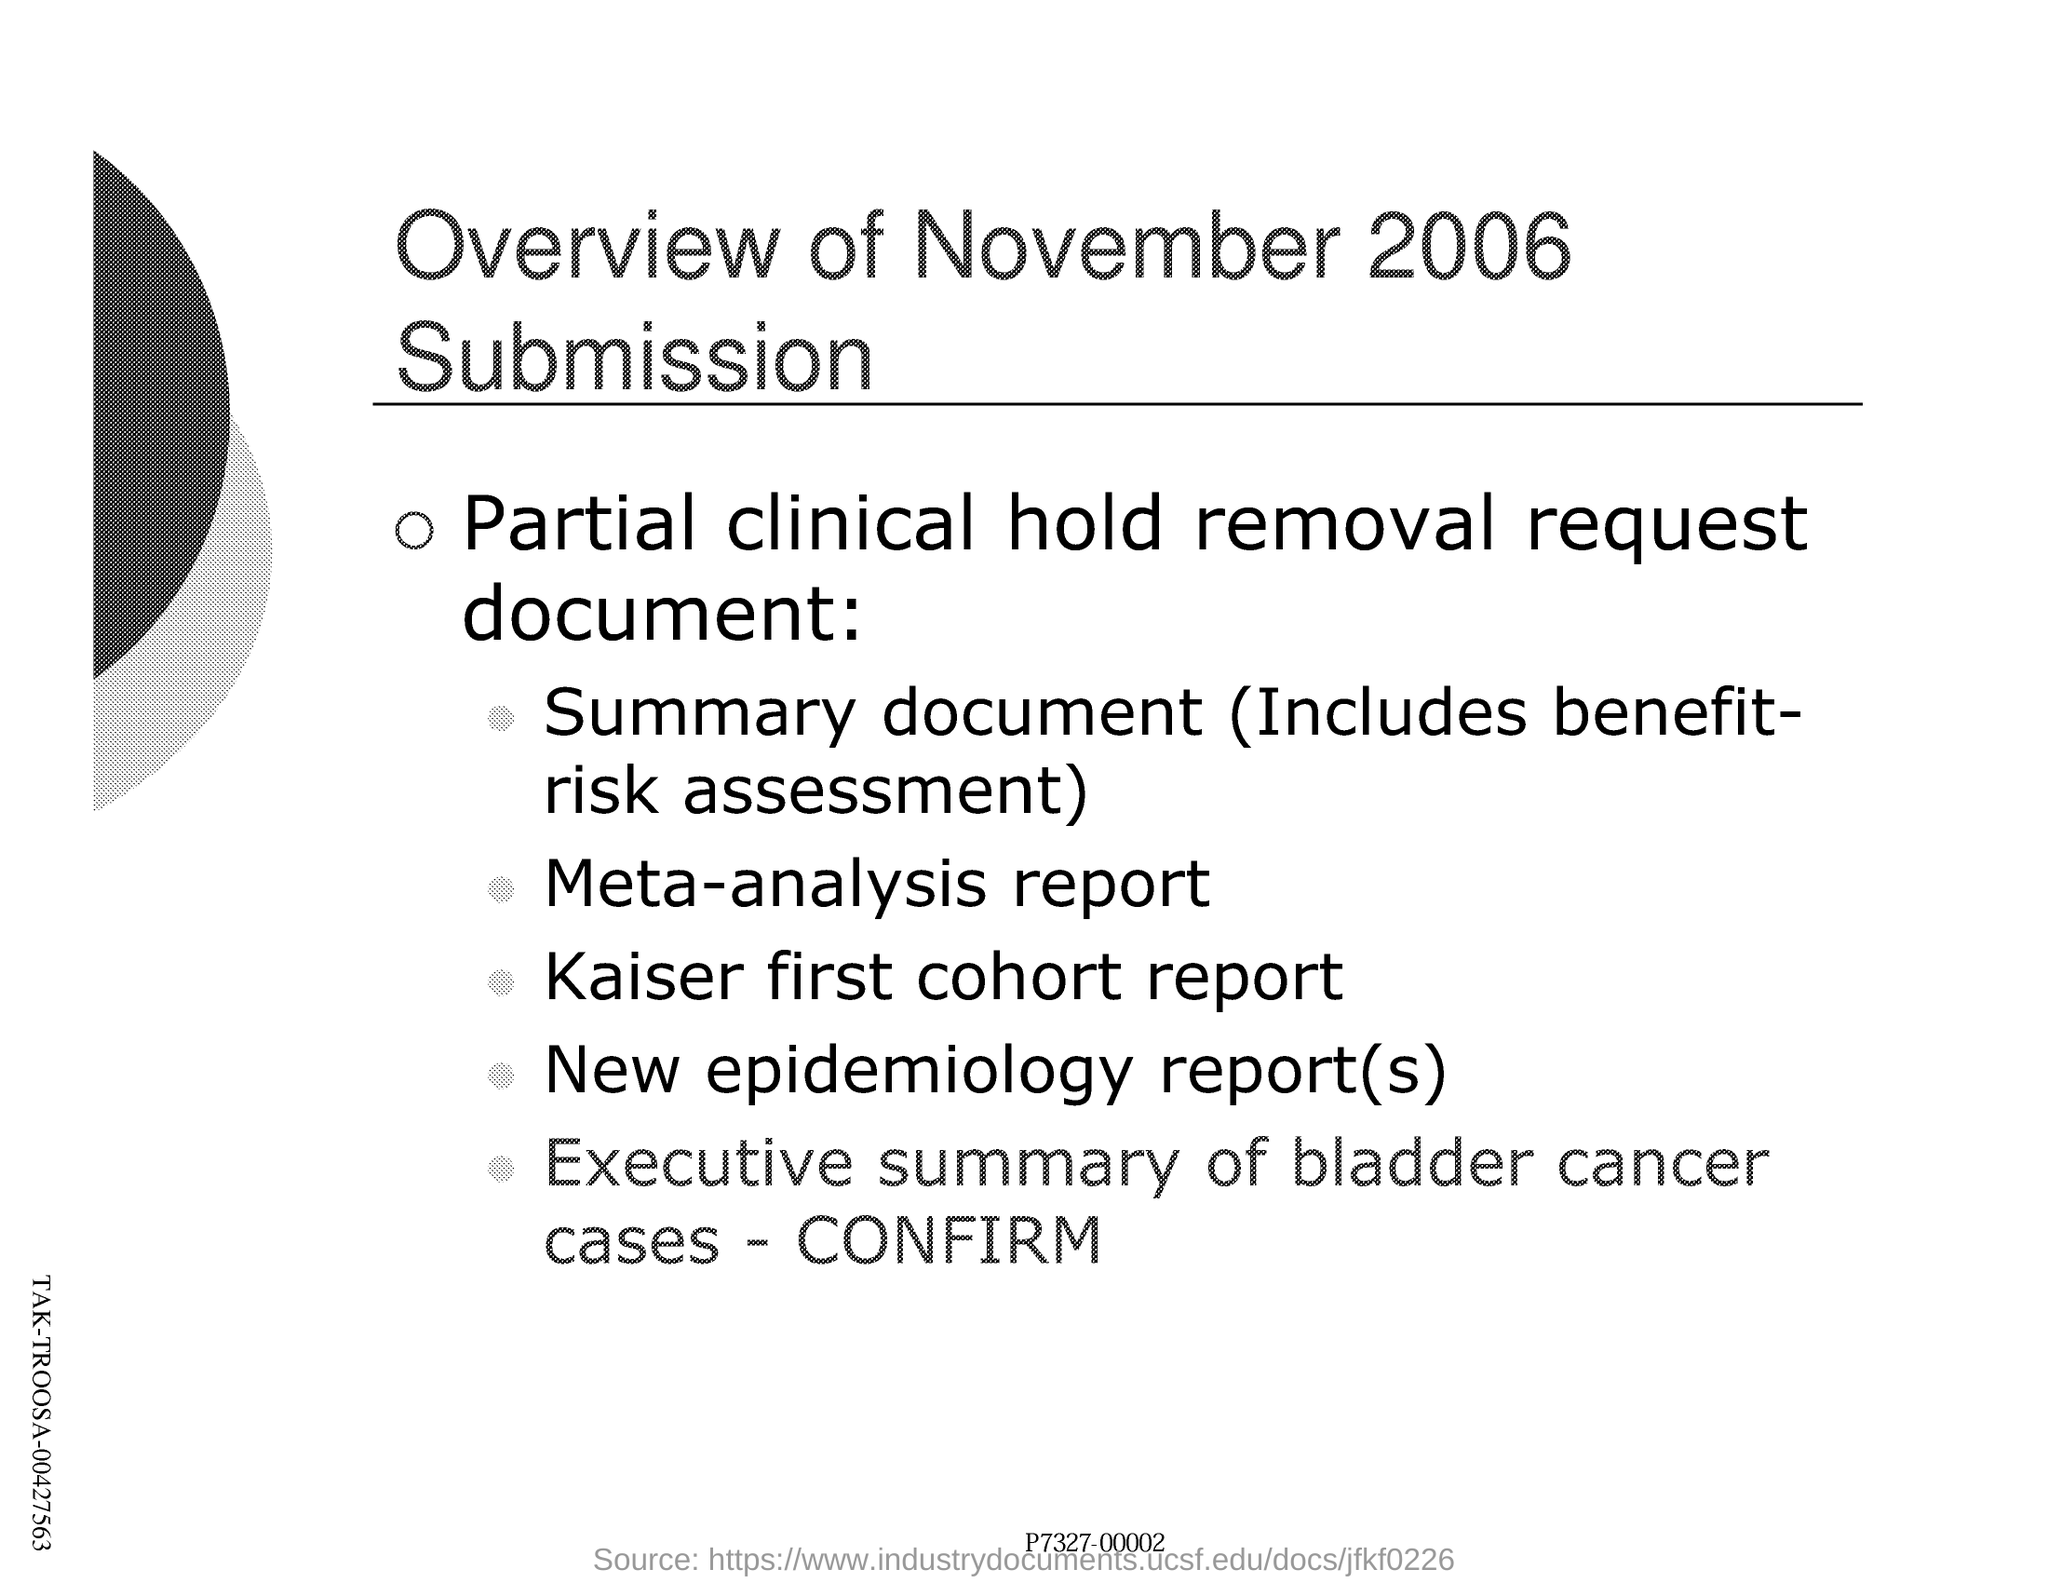What is the month and year of overview of submission ?
Your response must be concise. NOVEMBER 2006. What is included in the summary document ?
Offer a very short reply. (includes benefit-risk assessment). What is the executive summary of bladder cancer cases ?
Provide a succinct answer. CONFIRM. What is the name of the request document ?
Ensure brevity in your answer.  Partial clinical hold removal request document. 